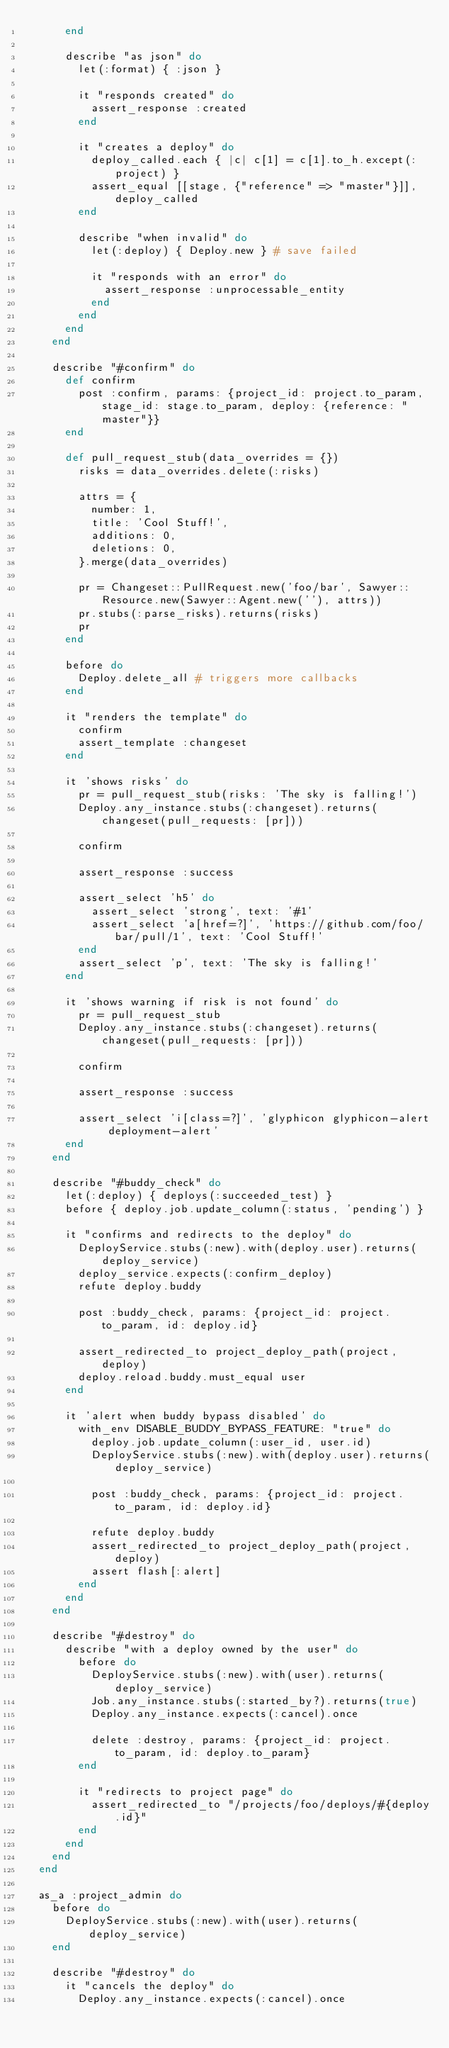Convert code to text. <code><loc_0><loc_0><loc_500><loc_500><_Ruby_>      end

      describe "as json" do
        let(:format) { :json }

        it "responds created" do
          assert_response :created
        end

        it "creates a deploy" do
          deploy_called.each { |c| c[1] = c[1].to_h.except(:project) }
          assert_equal [[stage, {"reference" => "master"}]], deploy_called
        end

        describe "when invalid" do
          let(:deploy) { Deploy.new } # save failed

          it "responds with an error" do
            assert_response :unprocessable_entity
          end
        end
      end
    end

    describe "#confirm" do
      def confirm
        post :confirm, params: {project_id: project.to_param, stage_id: stage.to_param, deploy: {reference: "master"}}
      end

      def pull_request_stub(data_overrides = {})
        risks = data_overrides.delete(:risks)

        attrs = {
          number: 1,
          title: 'Cool Stuff!',
          additions: 0,
          deletions: 0,
        }.merge(data_overrides)

        pr = Changeset::PullRequest.new('foo/bar', Sawyer::Resource.new(Sawyer::Agent.new(''), attrs))
        pr.stubs(:parse_risks).returns(risks)
        pr
      end

      before do
        Deploy.delete_all # triggers more callbacks
      end

      it "renders the template" do
        confirm
        assert_template :changeset
      end

      it 'shows risks' do
        pr = pull_request_stub(risks: 'The sky is falling!')
        Deploy.any_instance.stubs(:changeset).returns(changeset(pull_requests: [pr]))

        confirm

        assert_response :success

        assert_select 'h5' do
          assert_select 'strong', text: '#1'
          assert_select 'a[href=?]', 'https://github.com/foo/bar/pull/1', text: 'Cool Stuff!'
        end
        assert_select 'p', text: 'The sky is falling!'
      end

      it 'shows warning if risk is not found' do
        pr = pull_request_stub
        Deploy.any_instance.stubs(:changeset).returns(changeset(pull_requests: [pr]))

        confirm

        assert_response :success

        assert_select 'i[class=?]', 'glyphicon glyphicon-alert deployment-alert'
      end
    end

    describe "#buddy_check" do
      let(:deploy) { deploys(:succeeded_test) }
      before { deploy.job.update_column(:status, 'pending') }

      it "confirms and redirects to the deploy" do
        DeployService.stubs(:new).with(deploy.user).returns(deploy_service)
        deploy_service.expects(:confirm_deploy)
        refute deploy.buddy

        post :buddy_check, params: {project_id: project.to_param, id: deploy.id}

        assert_redirected_to project_deploy_path(project, deploy)
        deploy.reload.buddy.must_equal user
      end

      it 'alert when buddy bypass disabled' do
        with_env DISABLE_BUDDY_BYPASS_FEATURE: "true" do
          deploy.job.update_column(:user_id, user.id)
          DeployService.stubs(:new).with(deploy.user).returns(deploy_service)

          post :buddy_check, params: {project_id: project.to_param, id: deploy.id}

          refute deploy.buddy
          assert_redirected_to project_deploy_path(project, deploy)
          assert flash[:alert]
        end
      end
    end

    describe "#destroy" do
      describe "with a deploy owned by the user" do
        before do
          DeployService.stubs(:new).with(user).returns(deploy_service)
          Job.any_instance.stubs(:started_by?).returns(true)
          Deploy.any_instance.expects(:cancel).once

          delete :destroy, params: {project_id: project.to_param, id: deploy.to_param}
        end

        it "redirects to project page" do
          assert_redirected_to "/projects/foo/deploys/#{deploy.id}"
        end
      end
    end
  end

  as_a :project_admin do
    before do
      DeployService.stubs(:new).with(user).returns(deploy_service)
    end

    describe "#destroy" do
      it "cancels the deploy" do
        Deploy.any_instance.expects(:cancel).once</code> 